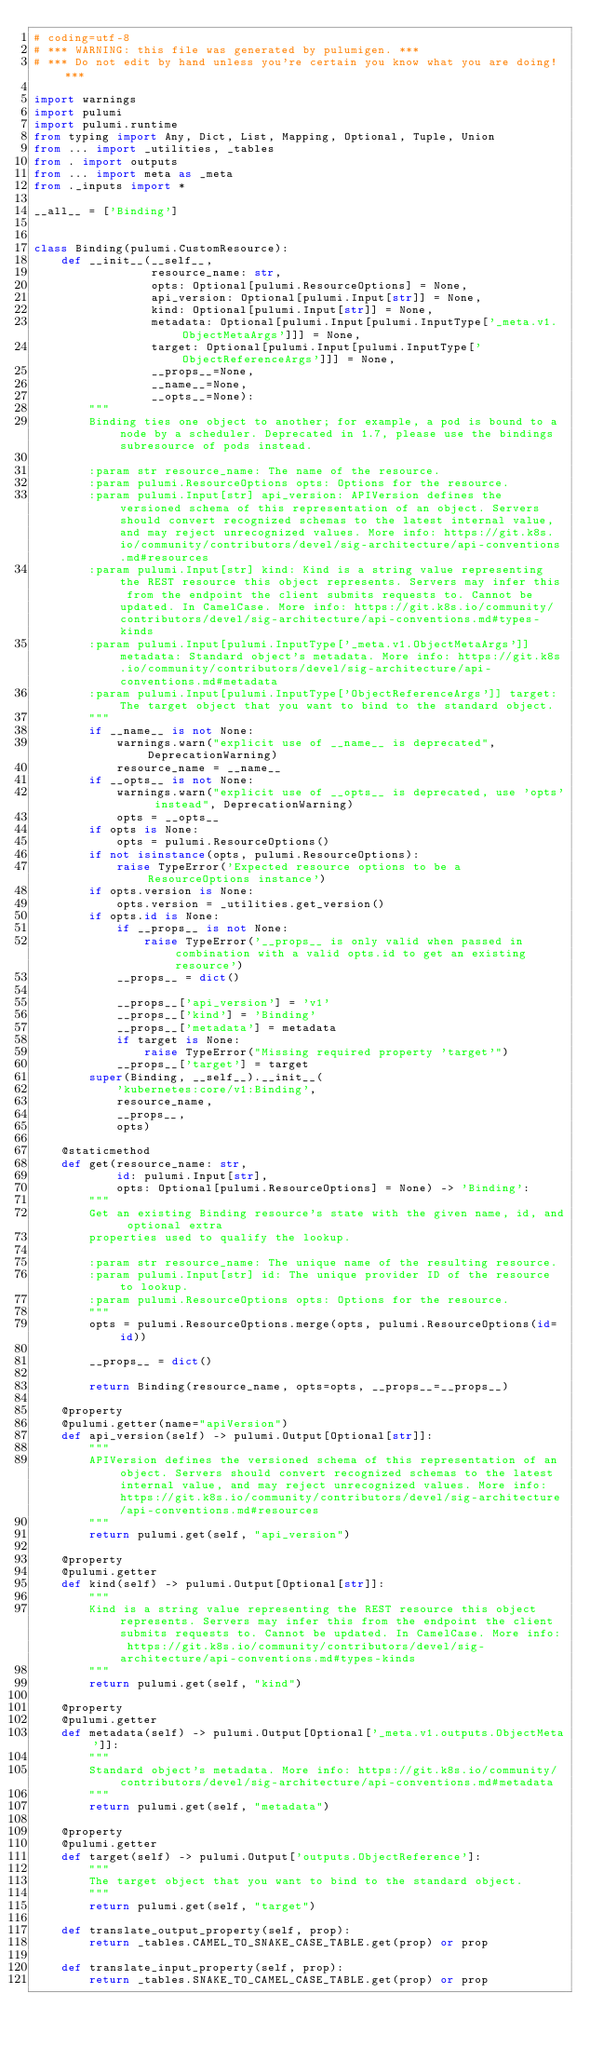Convert code to text. <code><loc_0><loc_0><loc_500><loc_500><_Python_># coding=utf-8
# *** WARNING: this file was generated by pulumigen. ***
# *** Do not edit by hand unless you're certain you know what you are doing! ***

import warnings
import pulumi
import pulumi.runtime
from typing import Any, Dict, List, Mapping, Optional, Tuple, Union
from ... import _utilities, _tables
from . import outputs
from ... import meta as _meta
from ._inputs import *

__all__ = ['Binding']


class Binding(pulumi.CustomResource):
    def __init__(__self__,
                 resource_name: str,
                 opts: Optional[pulumi.ResourceOptions] = None,
                 api_version: Optional[pulumi.Input[str]] = None,
                 kind: Optional[pulumi.Input[str]] = None,
                 metadata: Optional[pulumi.Input[pulumi.InputType['_meta.v1.ObjectMetaArgs']]] = None,
                 target: Optional[pulumi.Input[pulumi.InputType['ObjectReferenceArgs']]] = None,
                 __props__=None,
                 __name__=None,
                 __opts__=None):
        """
        Binding ties one object to another; for example, a pod is bound to a node by a scheduler. Deprecated in 1.7, please use the bindings subresource of pods instead.

        :param str resource_name: The name of the resource.
        :param pulumi.ResourceOptions opts: Options for the resource.
        :param pulumi.Input[str] api_version: APIVersion defines the versioned schema of this representation of an object. Servers should convert recognized schemas to the latest internal value, and may reject unrecognized values. More info: https://git.k8s.io/community/contributors/devel/sig-architecture/api-conventions.md#resources
        :param pulumi.Input[str] kind: Kind is a string value representing the REST resource this object represents. Servers may infer this from the endpoint the client submits requests to. Cannot be updated. In CamelCase. More info: https://git.k8s.io/community/contributors/devel/sig-architecture/api-conventions.md#types-kinds
        :param pulumi.Input[pulumi.InputType['_meta.v1.ObjectMetaArgs']] metadata: Standard object's metadata. More info: https://git.k8s.io/community/contributors/devel/sig-architecture/api-conventions.md#metadata
        :param pulumi.Input[pulumi.InputType['ObjectReferenceArgs']] target: The target object that you want to bind to the standard object.
        """
        if __name__ is not None:
            warnings.warn("explicit use of __name__ is deprecated", DeprecationWarning)
            resource_name = __name__
        if __opts__ is not None:
            warnings.warn("explicit use of __opts__ is deprecated, use 'opts' instead", DeprecationWarning)
            opts = __opts__
        if opts is None:
            opts = pulumi.ResourceOptions()
        if not isinstance(opts, pulumi.ResourceOptions):
            raise TypeError('Expected resource options to be a ResourceOptions instance')
        if opts.version is None:
            opts.version = _utilities.get_version()
        if opts.id is None:
            if __props__ is not None:
                raise TypeError('__props__ is only valid when passed in combination with a valid opts.id to get an existing resource')
            __props__ = dict()

            __props__['api_version'] = 'v1'
            __props__['kind'] = 'Binding'
            __props__['metadata'] = metadata
            if target is None:
                raise TypeError("Missing required property 'target'")
            __props__['target'] = target
        super(Binding, __self__).__init__(
            'kubernetes:core/v1:Binding',
            resource_name,
            __props__,
            opts)

    @staticmethod
    def get(resource_name: str,
            id: pulumi.Input[str],
            opts: Optional[pulumi.ResourceOptions] = None) -> 'Binding':
        """
        Get an existing Binding resource's state with the given name, id, and optional extra
        properties used to qualify the lookup.

        :param str resource_name: The unique name of the resulting resource.
        :param pulumi.Input[str] id: The unique provider ID of the resource to lookup.
        :param pulumi.ResourceOptions opts: Options for the resource.
        """
        opts = pulumi.ResourceOptions.merge(opts, pulumi.ResourceOptions(id=id))

        __props__ = dict()

        return Binding(resource_name, opts=opts, __props__=__props__)

    @property
    @pulumi.getter(name="apiVersion")
    def api_version(self) -> pulumi.Output[Optional[str]]:
        """
        APIVersion defines the versioned schema of this representation of an object. Servers should convert recognized schemas to the latest internal value, and may reject unrecognized values. More info: https://git.k8s.io/community/contributors/devel/sig-architecture/api-conventions.md#resources
        """
        return pulumi.get(self, "api_version")

    @property
    @pulumi.getter
    def kind(self) -> pulumi.Output[Optional[str]]:
        """
        Kind is a string value representing the REST resource this object represents. Servers may infer this from the endpoint the client submits requests to. Cannot be updated. In CamelCase. More info: https://git.k8s.io/community/contributors/devel/sig-architecture/api-conventions.md#types-kinds
        """
        return pulumi.get(self, "kind")

    @property
    @pulumi.getter
    def metadata(self) -> pulumi.Output[Optional['_meta.v1.outputs.ObjectMeta']]:
        """
        Standard object's metadata. More info: https://git.k8s.io/community/contributors/devel/sig-architecture/api-conventions.md#metadata
        """
        return pulumi.get(self, "metadata")

    @property
    @pulumi.getter
    def target(self) -> pulumi.Output['outputs.ObjectReference']:
        """
        The target object that you want to bind to the standard object.
        """
        return pulumi.get(self, "target")

    def translate_output_property(self, prop):
        return _tables.CAMEL_TO_SNAKE_CASE_TABLE.get(prop) or prop

    def translate_input_property(self, prop):
        return _tables.SNAKE_TO_CAMEL_CASE_TABLE.get(prop) or prop

</code> 